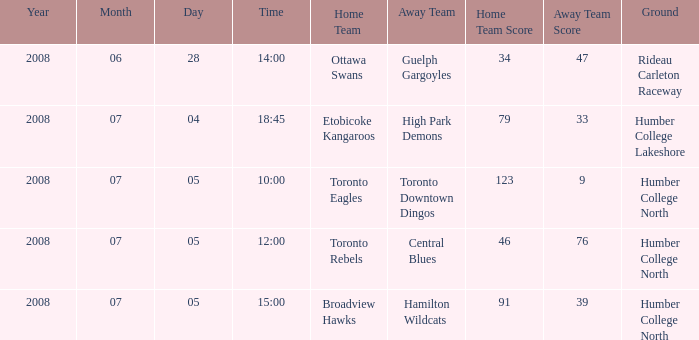What is the Score with a Date that is 2008-06-28? 34-47. 